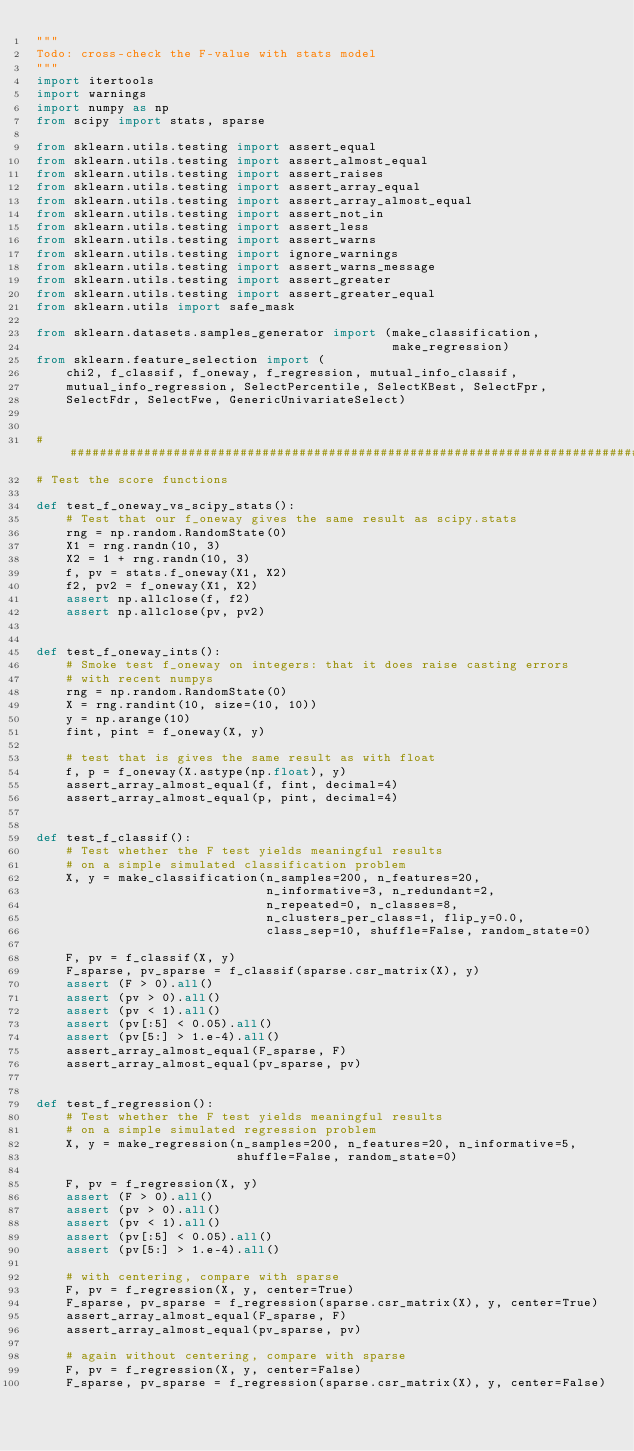<code> <loc_0><loc_0><loc_500><loc_500><_Python_>"""
Todo: cross-check the F-value with stats model
"""
import itertools
import warnings
import numpy as np
from scipy import stats, sparse

from sklearn.utils.testing import assert_equal
from sklearn.utils.testing import assert_almost_equal
from sklearn.utils.testing import assert_raises
from sklearn.utils.testing import assert_array_equal
from sklearn.utils.testing import assert_array_almost_equal
from sklearn.utils.testing import assert_not_in
from sklearn.utils.testing import assert_less
from sklearn.utils.testing import assert_warns
from sklearn.utils.testing import ignore_warnings
from sklearn.utils.testing import assert_warns_message
from sklearn.utils.testing import assert_greater
from sklearn.utils.testing import assert_greater_equal
from sklearn.utils import safe_mask

from sklearn.datasets.samples_generator import (make_classification,
                                                make_regression)
from sklearn.feature_selection import (
    chi2, f_classif, f_oneway, f_regression, mutual_info_classif,
    mutual_info_regression, SelectPercentile, SelectKBest, SelectFpr,
    SelectFdr, SelectFwe, GenericUnivariateSelect)


##############################################################################
# Test the score functions

def test_f_oneway_vs_scipy_stats():
    # Test that our f_oneway gives the same result as scipy.stats
    rng = np.random.RandomState(0)
    X1 = rng.randn(10, 3)
    X2 = 1 + rng.randn(10, 3)
    f, pv = stats.f_oneway(X1, X2)
    f2, pv2 = f_oneway(X1, X2)
    assert np.allclose(f, f2)
    assert np.allclose(pv, pv2)


def test_f_oneway_ints():
    # Smoke test f_oneway on integers: that it does raise casting errors
    # with recent numpys
    rng = np.random.RandomState(0)
    X = rng.randint(10, size=(10, 10))
    y = np.arange(10)
    fint, pint = f_oneway(X, y)

    # test that is gives the same result as with float
    f, p = f_oneway(X.astype(np.float), y)
    assert_array_almost_equal(f, fint, decimal=4)
    assert_array_almost_equal(p, pint, decimal=4)


def test_f_classif():
    # Test whether the F test yields meaningful results
    # on a simple simulated classification problem
    X, y = make_classification(n_samples=200, n_features=20,
                               n_informative=3, n_redundant=2,
                               n_repeated=0, n_classes=8,
                               n_clusters_per_class=1, flip_y=0.0,
                               class_sep=10, shuffle=False, random_state=0)

    F, pv = f_classif(X, y)
    F_sparse, pv_sparse = f_classif(sparse.csr_matrix(X), y)
    assert (F > 0).all()
    assert (pv > 0).all()
    assert (pv < 1).all()
    assert (pv[:5] < 0.05).all()
    assert (pv[5:] > 1.e-4).all()
    assert_array_almost_equal(F_sparse, F)
    assert_array_almost_equal(pv_sparse, pv)


def test_f_regression():
    # Test whether the F test yields meaningful results
    # on a simple simulated regression problem
    X, y = make_regression(n_samples=200, n_features=20, n_informative=5,
                           shuffle=False, random_state=0)

    F, pv = f_regression(X, y)
    assert (F > 0).all()
    assert (pv > 0).all()
    assert (pv < 1).all()
    assert (pv[:5] < 0.05).all()
    assert (pv[5:] > 1.e-4).all()

    # with centering, compare with sparse
    F, pv = f_regression(X, y, center=True)
    F_sparse, pv_sparse = f_regression(sparse.csr_matrix(X), y, center=True)
    assert_array_almost_equal(F_sparse, F)
    assert_array_almost_equal(pv_sparse, pv)

    # again without centering, compare with sparse
    F, pv = f_regression(X, y, center=False)
    F_sparse, pv_sparse = f_regression(sparse.csr_matrix(X), y, center=False)</code> 